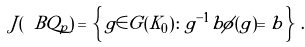<formula> <loc_0><loc_0><loc_500><loc_500>J ( \ B Q _ { p } ) \, = \, \left \{ \, g \in G ( K _ { 0 } ) \colon g ^ { - 1 } b \phi ( g ) = b \, \right \} \, .</formula> 